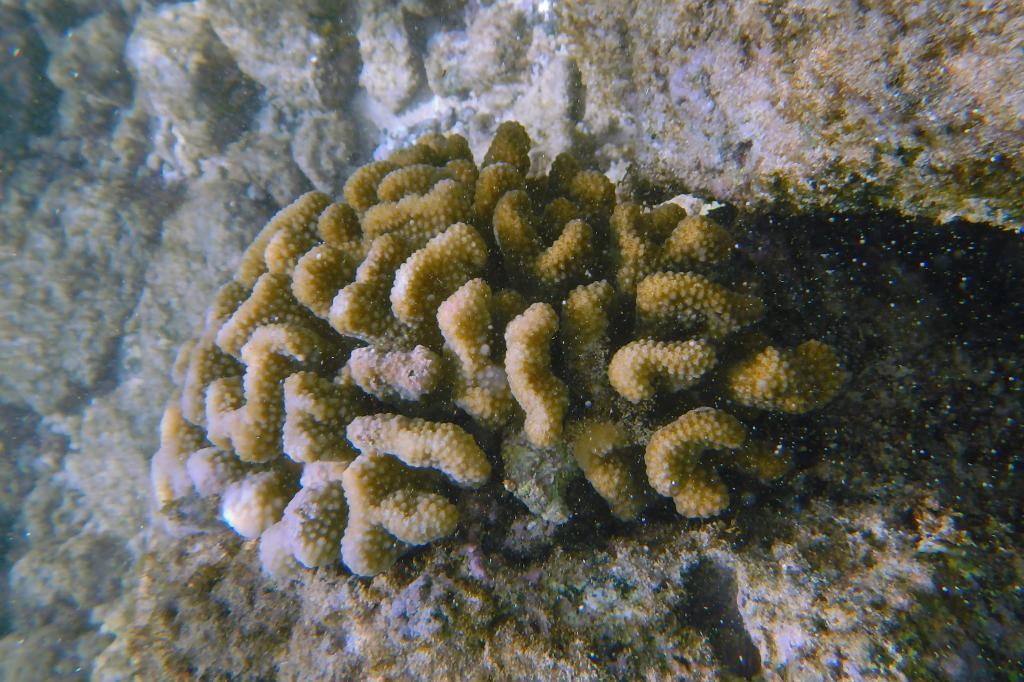What type of plants can be seen in the image? There are underwater plants in the image. What color is the orange in the image? There is no orange present in the image; it features underwater plants. What thoughts are going through the mind of the underwater plants in the image? Underwater plants do not have minds, so it is not possible to determine their thoughts. 